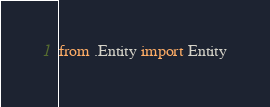<code> <loc_0><loc_0><loc_500><loc_500><_Python_>
from .Entity import Entity</code> 